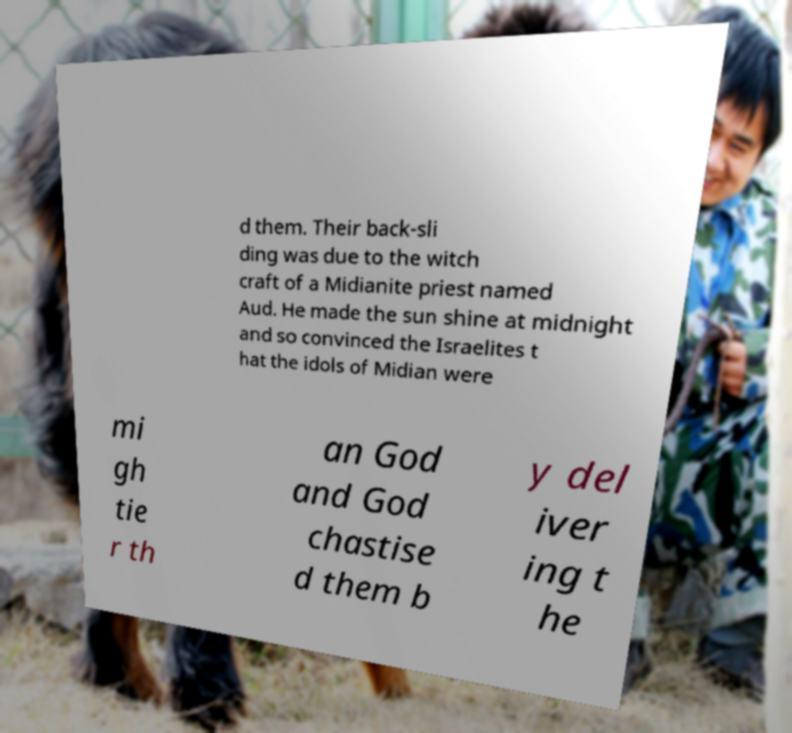Please identify and transcribe the text found in this image. d them. Their back-sli ding was due to the witch craft of a Midianite priest named Aud. He made the sun shine at midnight and so convinced the Israelites t hat the idols of Midian were mi gh tie r th an God and God chastise d them b y del iver ing t he 